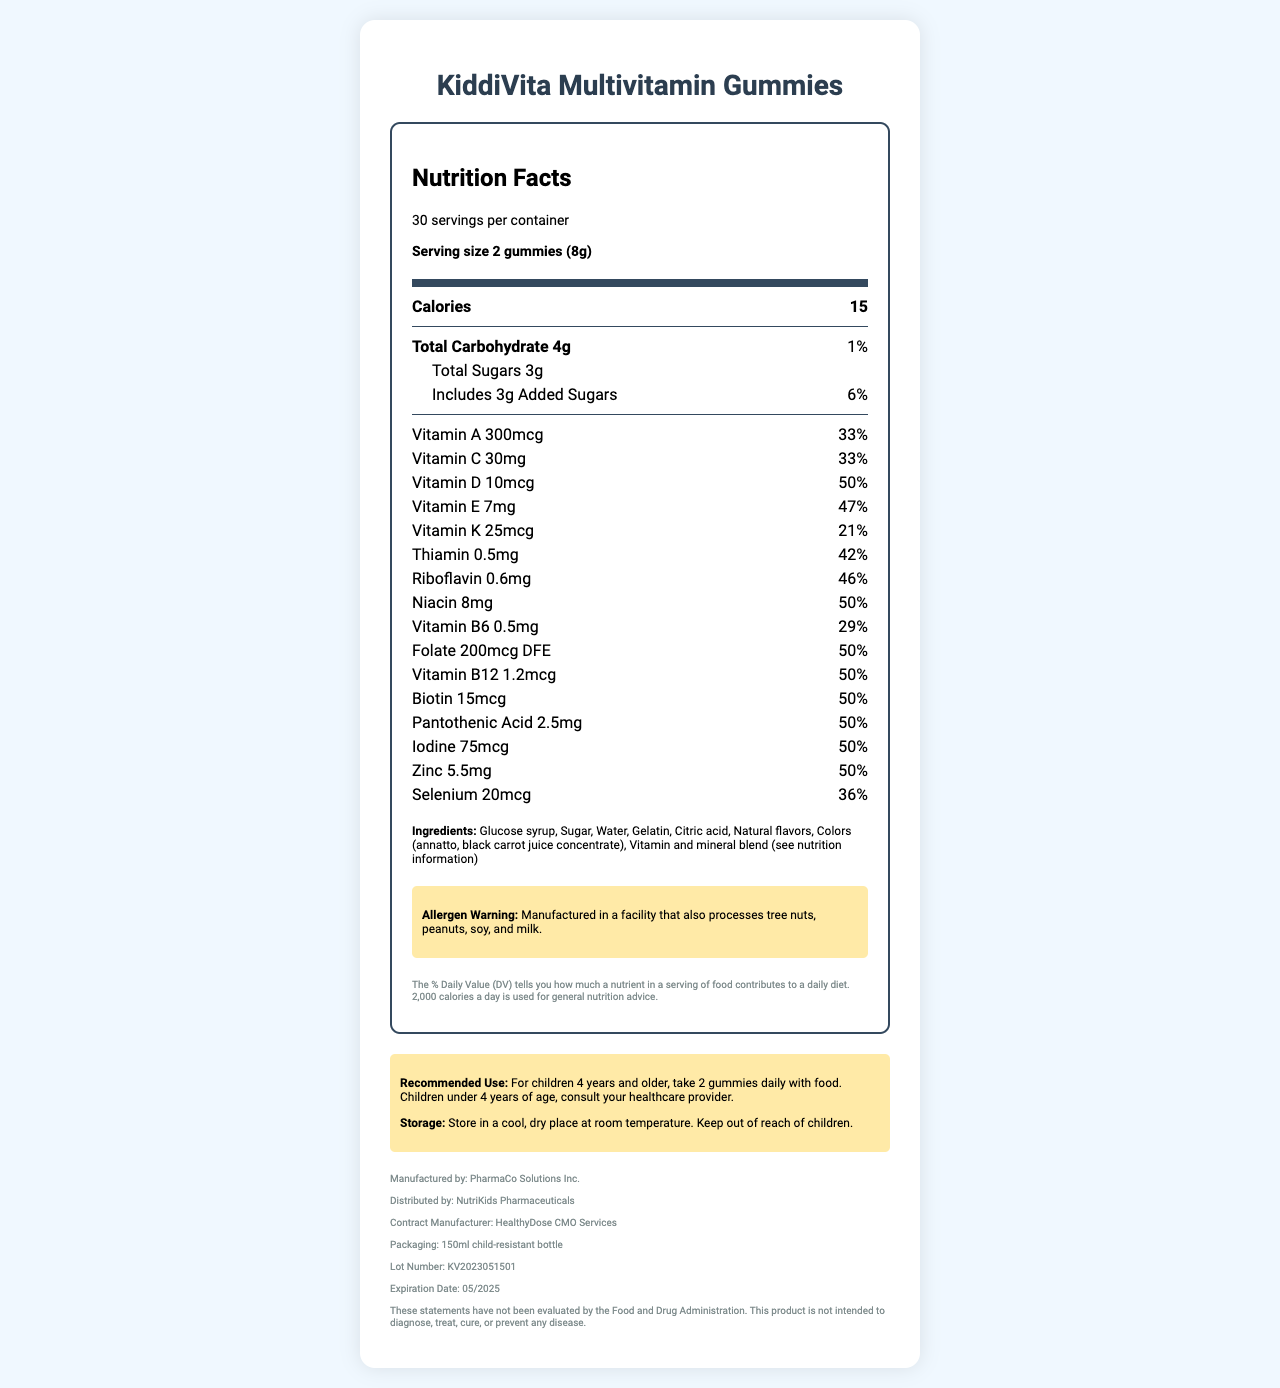what is the serving size? The serving size is explicitly mentioned as "2 gummies (8g)" in the serving information section.
Answer: 2 gummies (8g) what is the recommended use for this product? The recommended use is detailed in the warning box at the bottom of the document.
Answer: For children 4 years and older, take 2 gummies daily with food. Children under 4 years of age, consult your healthcare provider. how many calories are in one serving? The nutrient row listing "Calories" shows that there are 15 calories in one serving.
Answer: 15 what allergens are processed in the manufacturing facility? The allergen warning section states that the product is manufactured in a facility that processes tree nuts, peanuts, soy, and milk.
Answer: Tree nuts, peanuts, soy, and milk what is the expiration date of this product? The expiration date is listed in the footnote section at the bottom of the document.
Answer: 05/2025 which manufacturer is responsible for this product? A. PharmaCo Solutions Inc. B. NutriKids Pharmaceuticals C. HealthyDose CMO Services The footnote reveals that "PharmaCo Solutions Inc." is the manufacturer.
Answer: A what is the percentage daily value of vitamin D? A. 33% B. 42% C. 50% D. 21% The nutrient row listing "Vitamin D" shows that the daily value percentage is 50%.
Answer: C is there any biotin in this gummy? The nutrient rows show "Biotin" with an amount and percentage daily value.
Answer: Yes is this product approved by the FDA to diagnose, treat, cure, or prevent any disease? The footnote disclaimer expressly states, "This product is not intended to diagnose, treat, cure, or prevent any disease."
Answer: No summarize the main details of the KiddiVita Multivitamin Gummies document. The document provides an overview of the nutritional content, ingredients, usage instructions, and manufacturing details of the KiddiVita Multivitamin Gummies.
Answer: The document provides detailed nutrition facts, serving sizes, ingredient information, allergen warnings, recommended use instructions, storage instructions, and manufacturer details for "KiddiVita Multivitamin Gummies". The nutritional data includes calories, carbohydrates, sugars, and a comprehensive list of vitamins and minerals. It also highlights the manufacturing and distribution entities, and includes a disclaimer regarding FDA approval. what is the main color mentioned in the ingredients for coloring? The ingredients section lists "Colors (annatto, black carrot juice concentrate)" as the sources of color.
Answer: Annatto, black carrot juice concentrate how many servings per container are there? The serving information section states there are 30 servings per container.
Answer: 30 what packaging type is used for this product? The footnote section at the bottom specifies that the packaging is a "150ml child-resistant bottle".
Answer: 150ml child-resistant bottle can we determine the manufacturing date of this product from the document? The document does not contain the manufacturing date; it only lists the lot number and expiration date.
Answer: Cannot be determined 